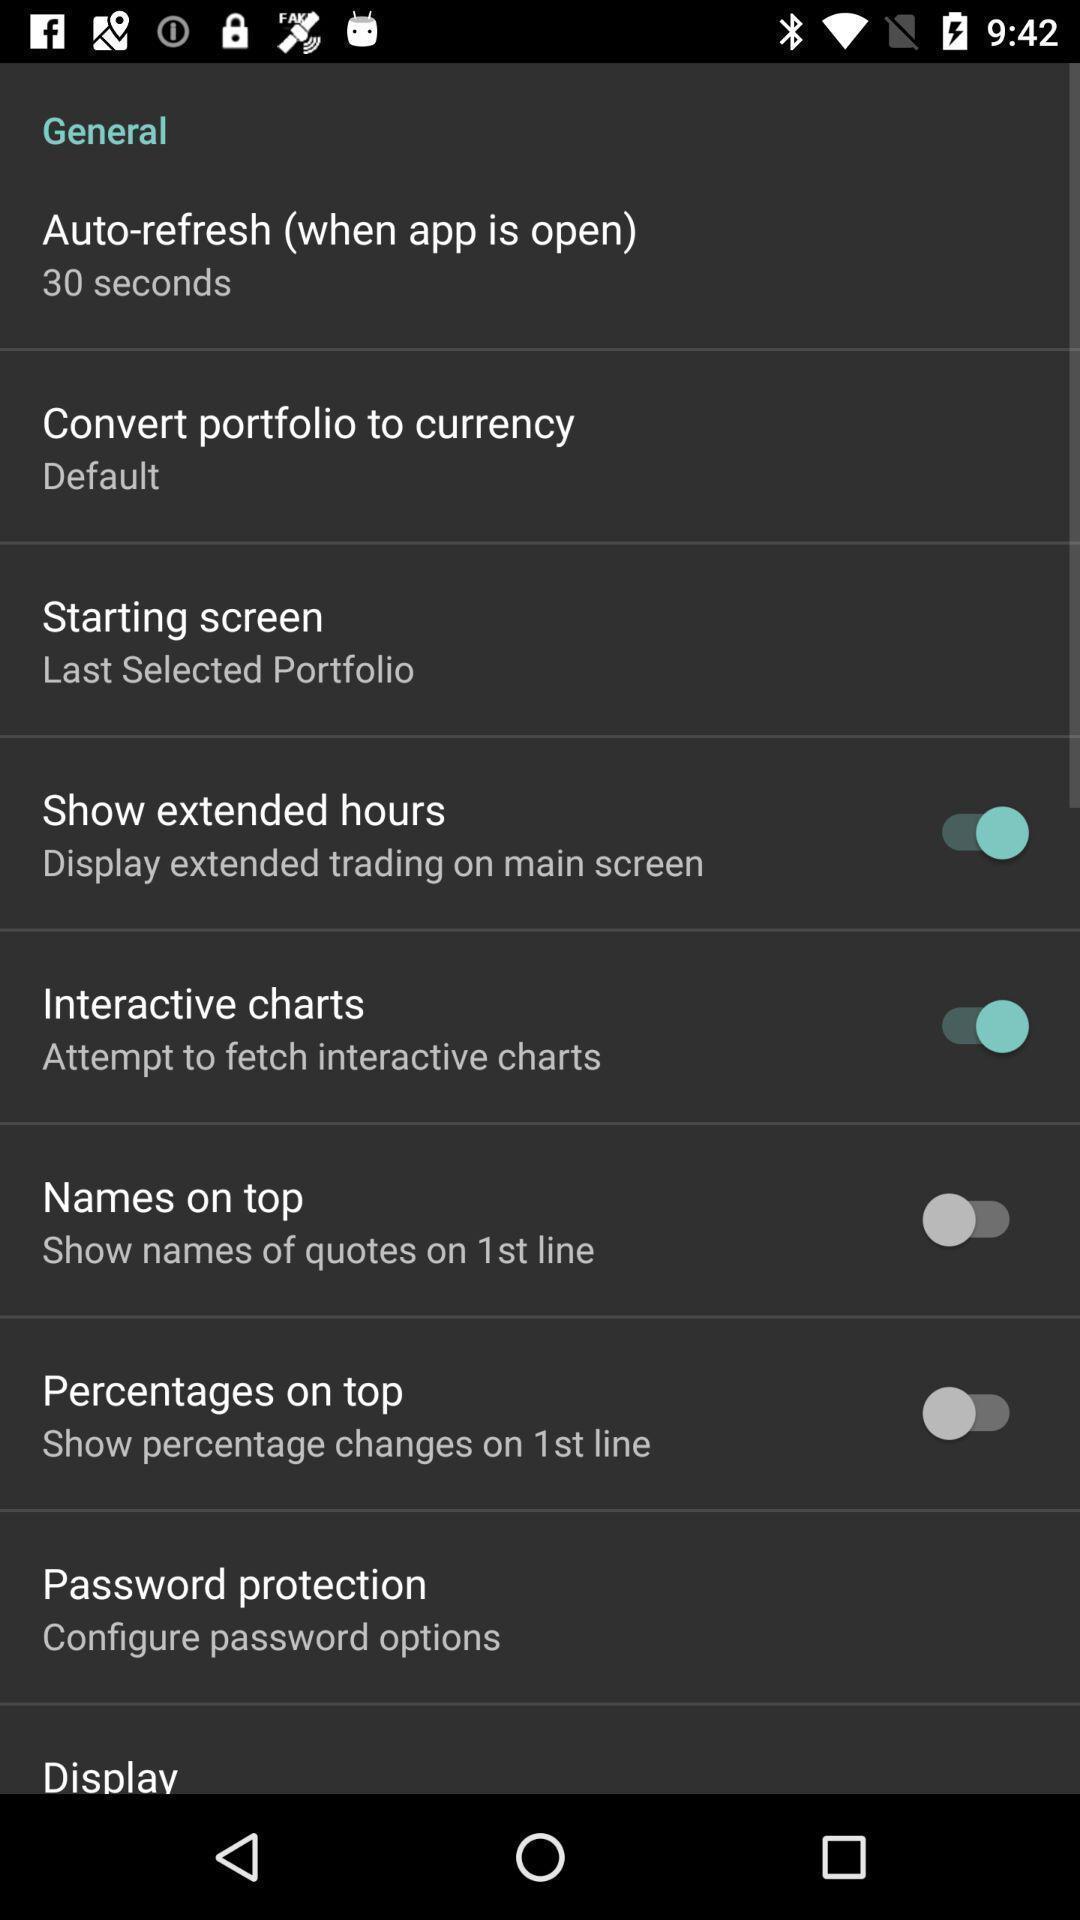What details can you identify in this image? Screen showing general settings options. 